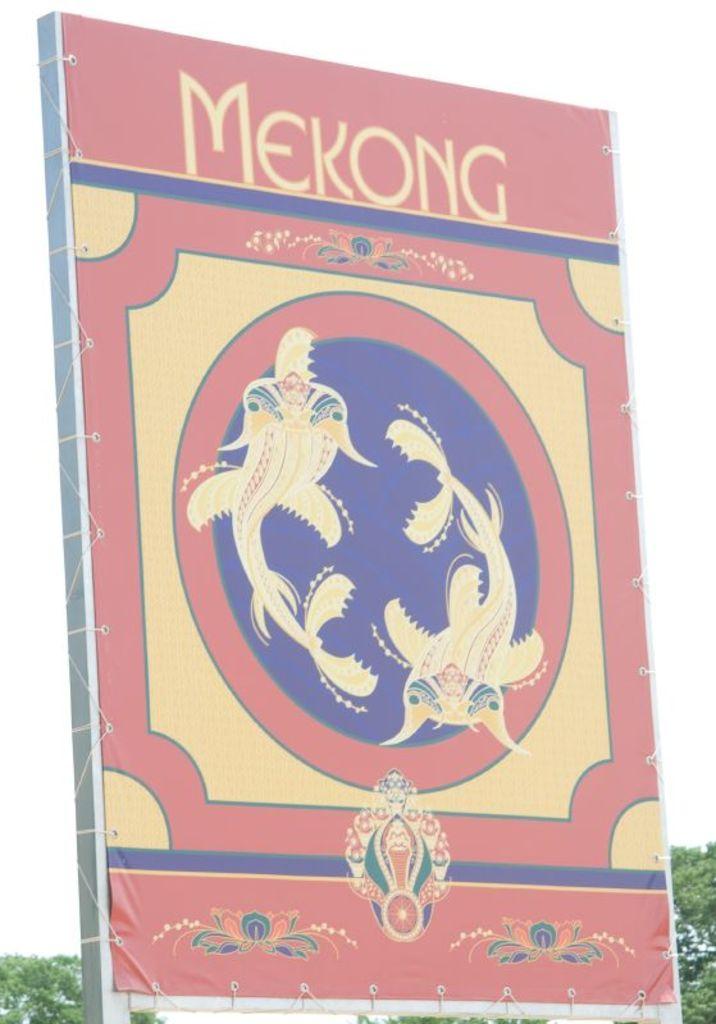What does the sign say?
Provide a short and direct response. Mekong. What is the first letter of the word on the sign?
Offer a very short reply. M. 